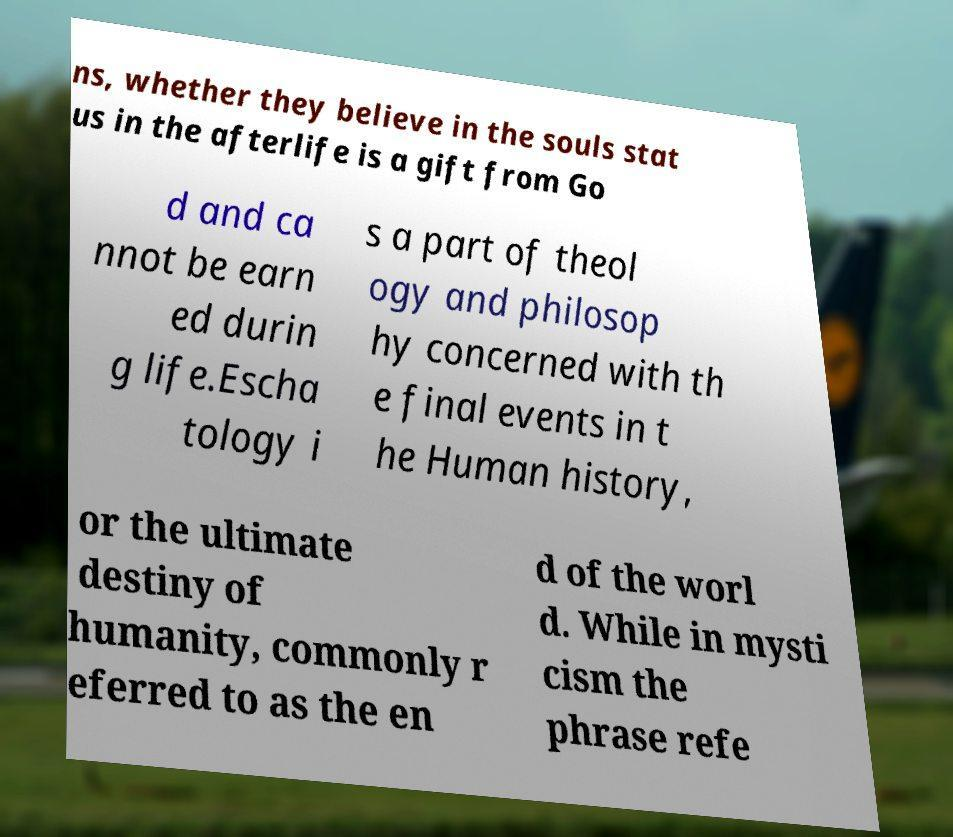Can you read and provide the text displayed in the image?This photo seems to have some interesting text. Can you extract and type it out for me? ns, whether they believe in the souls stat us in the afterlife is a gift from Go d and ca nnot be earn ed durin g life.Escha tology i s a part of theol ogy and philosop hy concerned with th e final events in t he Human history, or the ultimate destiny of humanity, commonly r eferred to as the en d of the worl d. While in mysti cism the phrase refe 